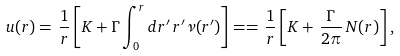<formula> <loc_0><loc_0><loc_500><loc_500>u ( r ) = \, \frac { 1 } { r } \left [ K + \Gamma \int _ { 0 } ^ { r } d r ^ { \prime } \, r ^ { \prime } \nu ( r ^ { \prime } ) \right ] = = \, \frac { 1 } { r } \left [ K + \, \frac { \Gamma } { 2 \pi } \, N ( r ) \right ] ,</formula> 